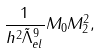<formula> <loc_0><loc_0><loc_500><loc_500>\frac { 1 } { h ^ { 2 } \tilde { \Lambda } _ { e l } ^ { 9 } } M _ { 0 } M _ { 2 } ^ { 2 } ,</formula> 